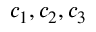Convert formula to latex. <formula><loc_0><loc_0><loc_500><loc_500>c _ { 1 } , c _ { 2 } , c _ { 3 }</formula> 